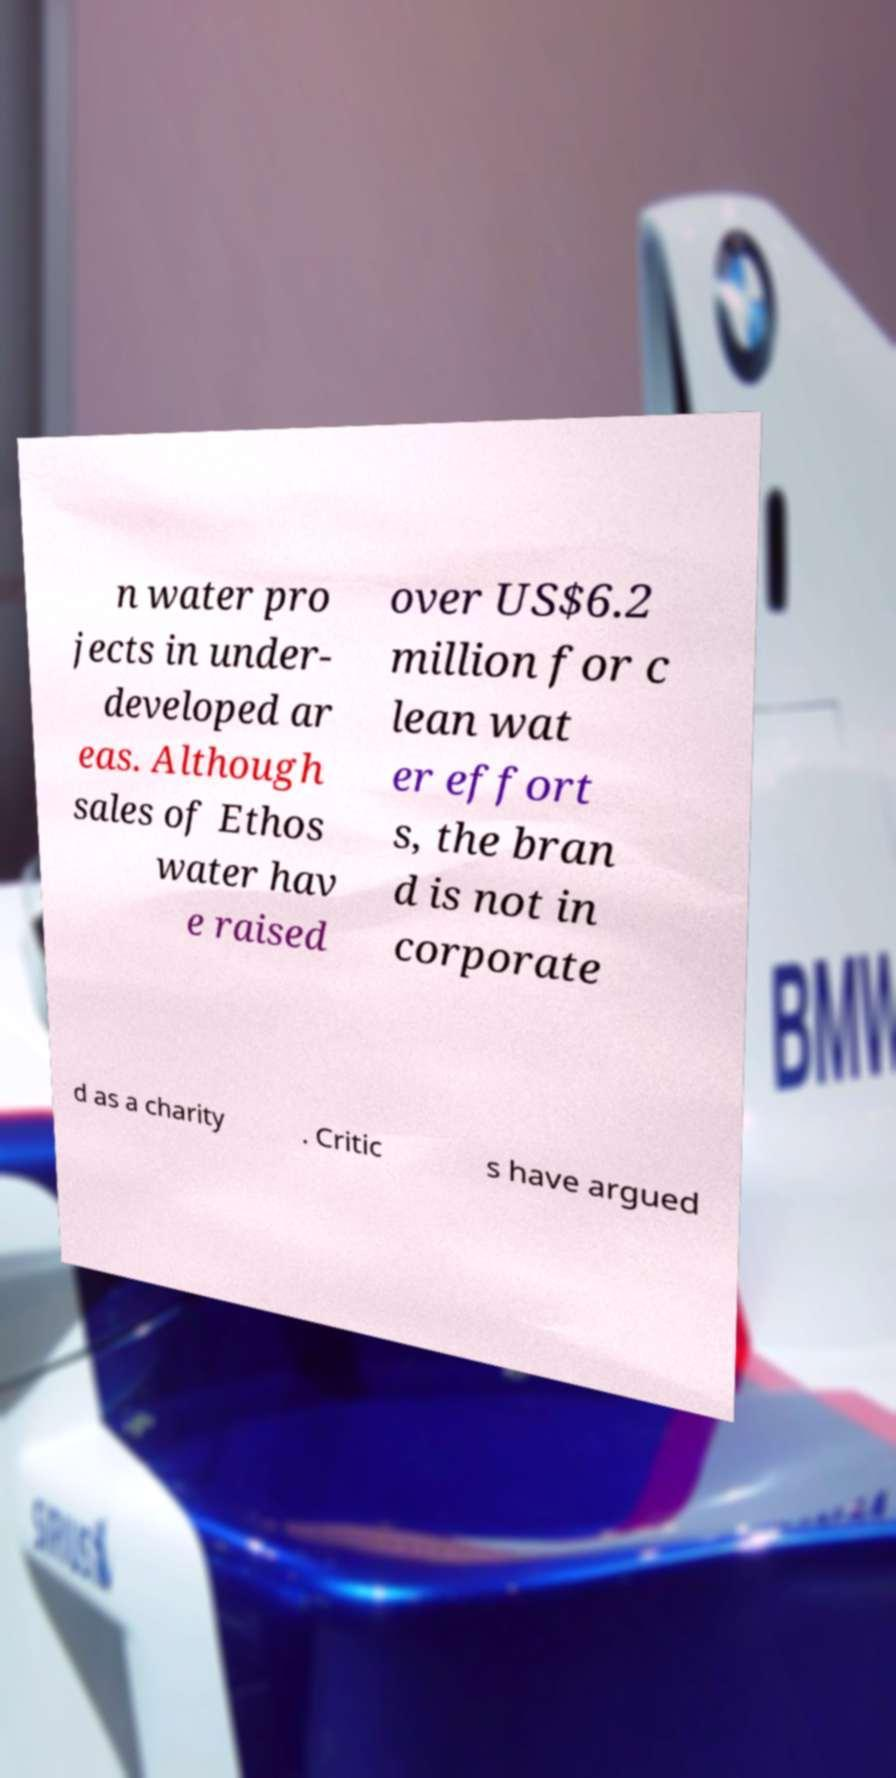Could you assist in decoding the text presented in this image and type it out clearly? n water pro jects in under- developed ar eas. Although sales of Ethos water hav e raised over US$6.2 million for c lean wat er effort s, the bran d is not in corporate d as a charity . Critic s have argued 